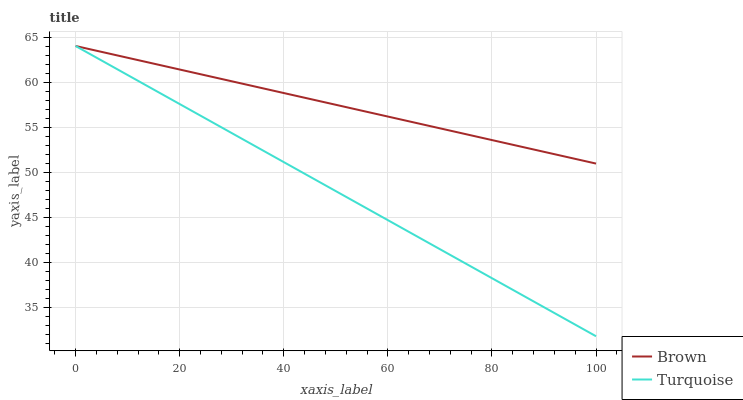Does Turquoise have the minimum area under the curve?
Answer yes or no. Yes. Does Brown have the maximum area under the curve?
Answer yes or no. Yes. Does Turquoise have the maximum area under the curve?
Answer yes or no. No. Is Brown the smoothest?
Answer yes or no. Yes. Is Turquoise the roughest?
Answer yes or no. Yes. Is Turquoise the smoothest?
Answer yes or no. No. Does Turquoise have the lowest value?
Answer yes or no. Yes. Does Turquoise have the highest value?
Answer yes or no. Yes. Does Brown intersect Turquoise?
Answer yes or no. Yes. Is Brown less than Turquoise?
Answer yes or no. No. Is Brown greater than Turquoise?
Answer yes or no. No. 